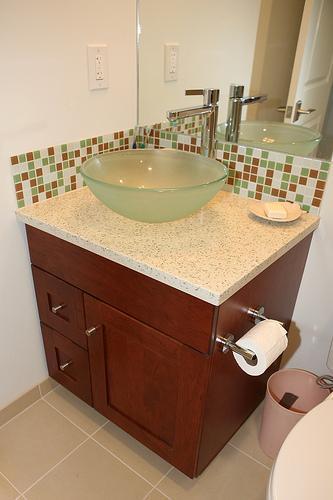How many doors are in the cabinet?
Give a very brief answer. 1. How many drawers are in the base of the sink?
Give a very brief answer. 2. How many toilet paper rolls are there?
Give a very brief answer. 1. 